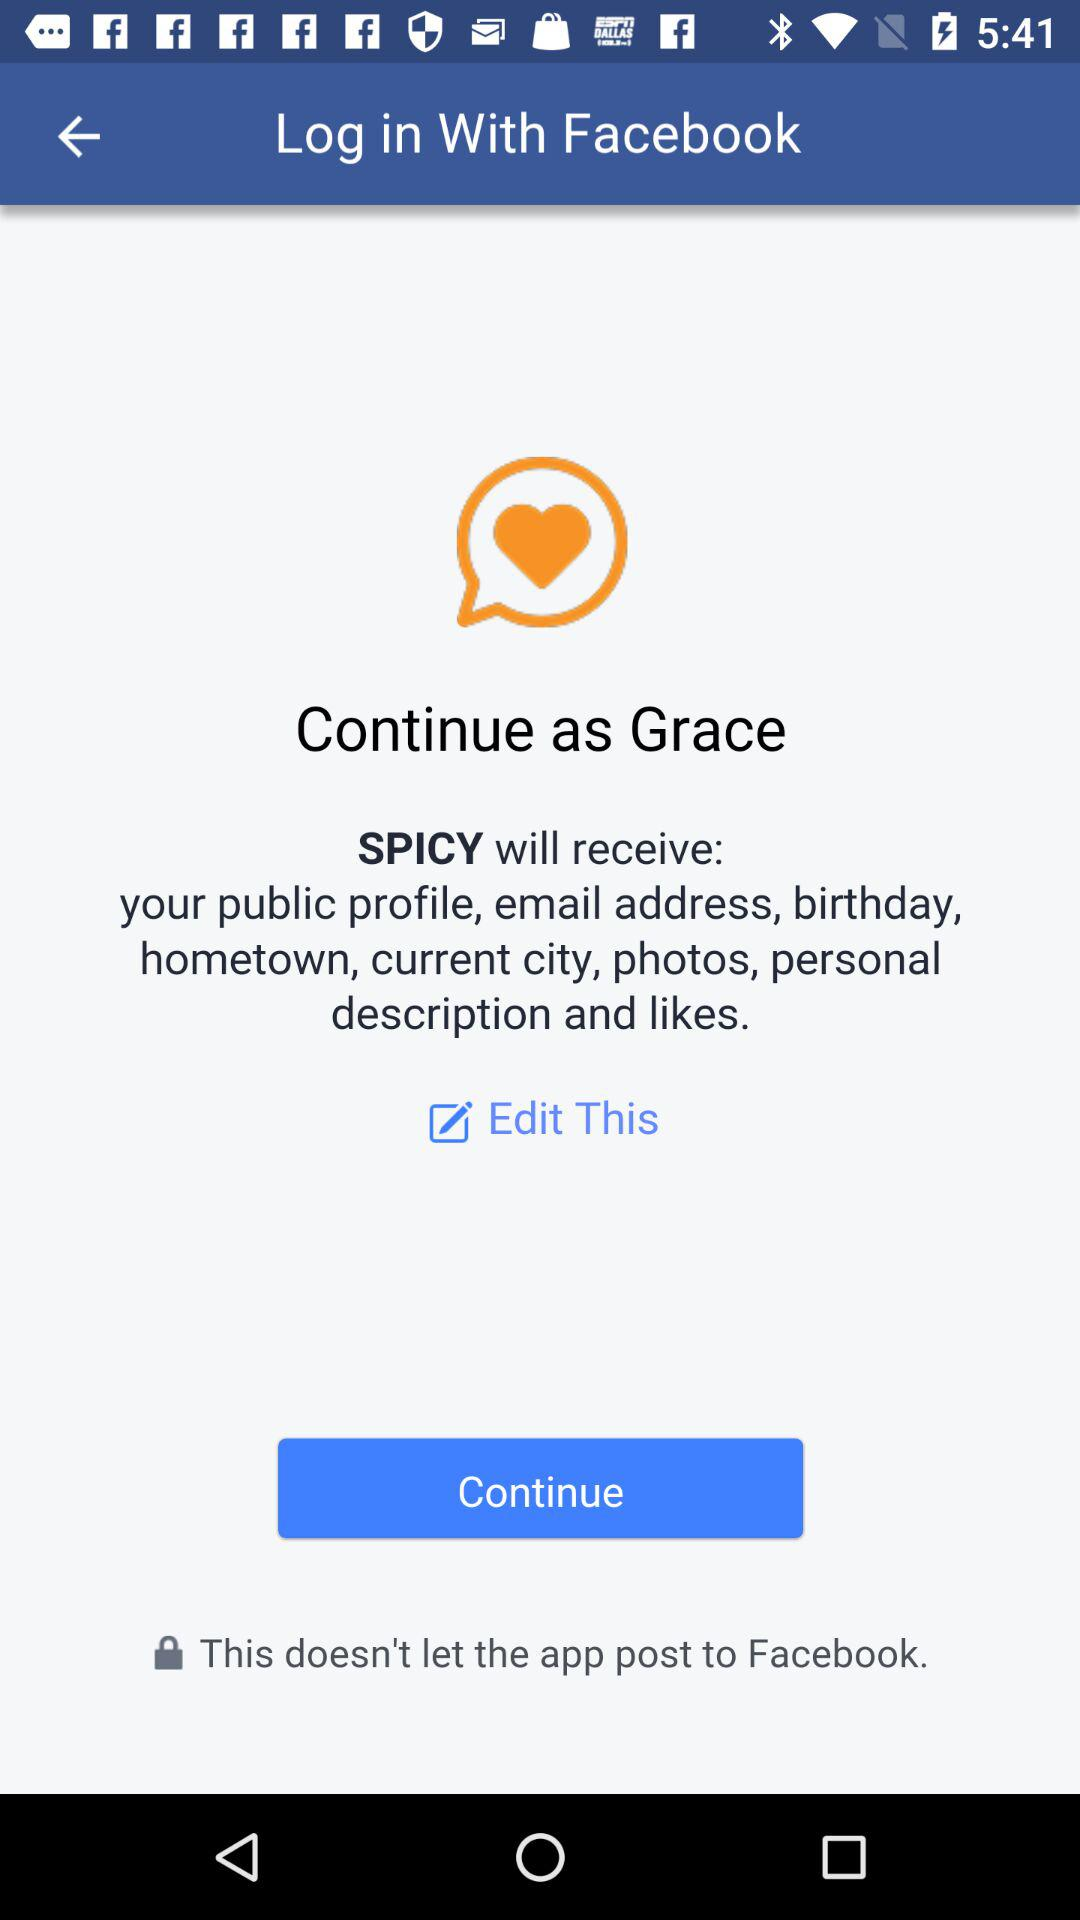What application will receive my public profile, email address, birthday and hometown? The application that will receive your public profile, email address, birthday and hometown is "SPICY". 